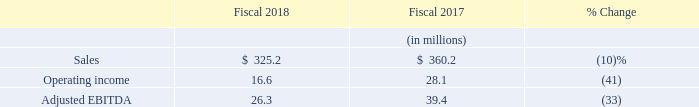Cubic Global Defense
Sales: CGD sales decreased 10% to $325.2 million in 2018 compared to $360.2 million in 2017. The year-over-year comparative sales and operating income were significantly impacted by an $8.0 million gain recognized on an equitable contract adjustment in fiscal 2017 for our littoral combat ship virtual training contract with the U.S. Navy. Sales were lower in fiscal 2018 on virtual training sales, air combat training system sales, and ground combat training system sales, while sales of international training support services increased between fiscal 2017 and 2018. The average exchange rates between the prevailing currency in our foreign operations and the U.S. dollar had no significant impact on CGD sales between 2017 and 2018.
Amortization of Purchased Intangibles: Amortization of purchased intangibles included in the CGD results amounted to $1.1 million in 2018 and $0.9 million in 2017.
Operating Income: CGD had operating income of $16.6 million in 2018 compared to $28.1 million in 2017. The decrease in operating income was primarily caused by the gain of $8.0 million recognized in fiscal 2017 due to the approval of a contract adjustment with the U.S. Navy described above. In fiscal 2018 an arbitrator awarded $1.7 million to a former reseller of our air combat training systems in the Far East, which was recorded as SG&A expense by CGD in 2018. In addition, CGD’s R&D expenditures increased approximately $1.8 million year-over-year. The increase in R&D expenditures is indicative of the acceleration of our development of next generation live, virtual, constructive, and game-based training systems. These decreases in operating income in fiscal 2018 were partially offset by increased operating income from ground combat training systems, which was higher primarily due to improvements in expected total costs for the development of two ground combat training system contracts in the Far East. The average exchange rates between the prevailing currency in our foreign operations and the U.S. dollar had no significant impact on CGD operating income between 2017 and 2018.
Adjusted EBITDA: CGD Adjusted EBITDA was $26.3 million in 2018 compared to $39.4 million in 2017. The decrease in Adjusted EBITDA was primarily driven by the same factors that drove the decrease in operating income described above excluding the increase in amortization which is excluded from Adjusted EBITDA.
What is the percentage change in CGD sales in 2018? Decreased 10%. What is the increase in R&D expenditures indicative of? The acceleration of our development of next generation live, virtual, constructive, and game-based training systems. For which years is the amortization of purchased intangibles included in the CGD results recorded? 2018, 2017. In which year is the amortization of purchased intangibles included in the CGD results larger? 1.1>0.9
Answer: 2018. What is the change in operating income from 2017 to 2018?
Answer scale should be: million. 16.6-28.1
Answer: -11.5. What is the average adjusted EBITDA in 2017 and 2018?
Answer scale should be: million. (26.3+39.4)/2
Answer: 32.85. 